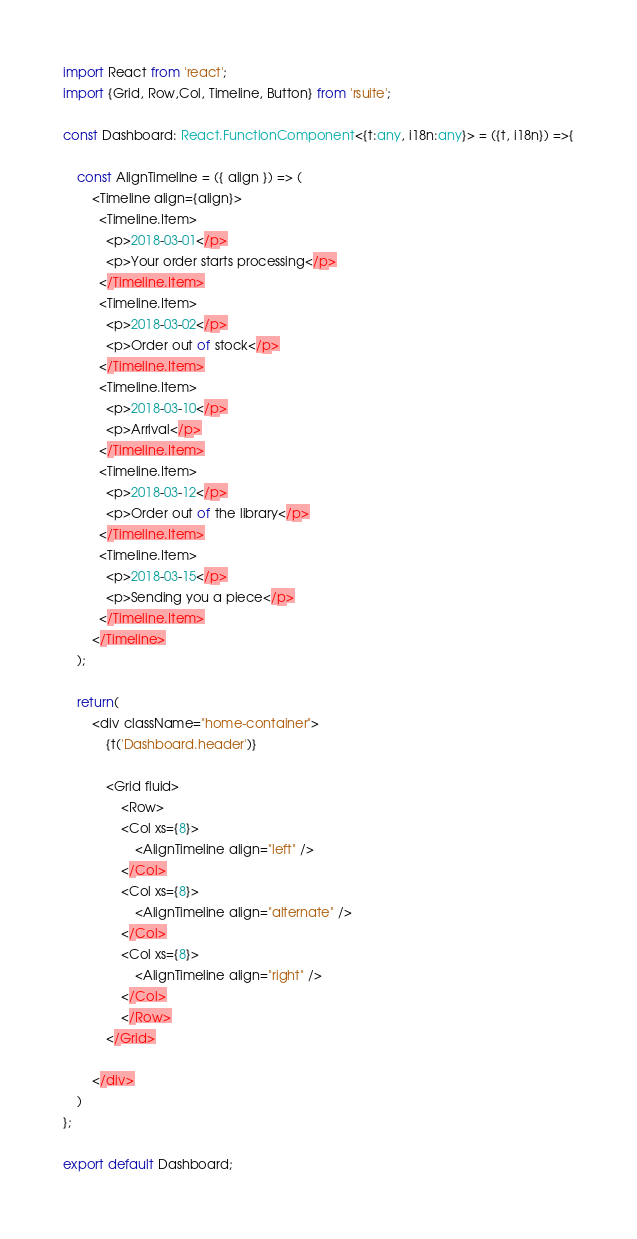Convert code to text. <code><loc_0><loc_0><loc_500><loc_500><_TypeScript_>import React from 'react';
import {Grid, Row,Col, Timeline, Button} from 'rsuite';

const Dashboard: React.FunctionComponent<{t:any, i18n:any}> = ({t, i18n}) =>{

    const AlignTimeline = ({ align }) => (
        <Timeline align={align}>
          <Timeline.Item>
            <p>2018-03-01</p>
            <p>Your order starts processing</p>
          </Timeline.Item>
          <Timeline.Item>
            <p>2018-03-02</p>
            <p>Order out of stock</p>
          </Timeline.Item>
          <Timeline.Item>
            <p>2018-03-10</p>
            <p>Arrival</p>
          </Timeline.Item>
          <Timeline.Item>
            <p>2018-03-12</p>
            <p>Order out of the library</p>
          </Timeline.Item>
          <Timeline.Item>
            <p>2018-03-15</p>
            <p>Sending you a piece</p>
          </Timeline.Item>
        </Timeline>
    );
    
    return(
        <div className="home-container">
            {t('Dashboard.header')}

            <Grid fluid>
                <Row>
                <Col xs={8}>
                    <AlignTimeline align="left" />
                </Col>
                <Col xs={8}>
                    <AlignTimeline align="alternate" />
                </Col>
                <Col xs={8}>
                    <AlignTimeline align="right" />
                </Col>
                </Row>
            </Grid>

        </div>
    )
};

export default Dashboard;</code> 